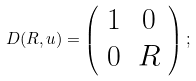Convert formula to latex. <formula><loc_0><loc_0><loc_500><loc_500>D ( R , u ) = \left ( \begin{array} { c c } { 1 } & { 0 } \\ { { 0 } } & { R } \end{array} \right ) ;</formula> 